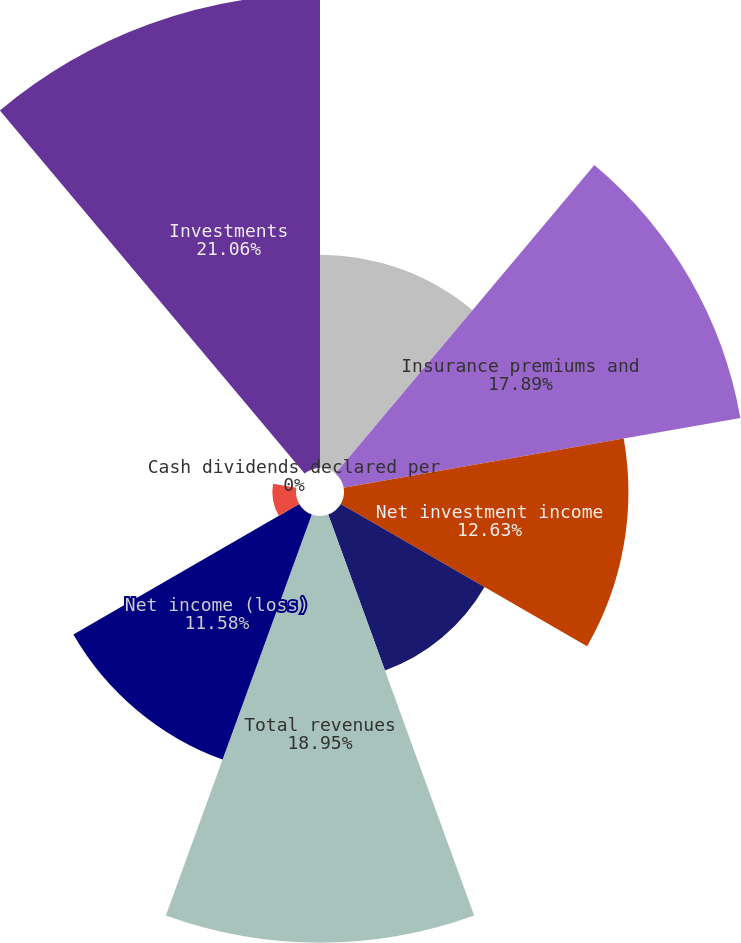<chart> <loc_0><loc_0><loc_500><loc_500><pie_chart><fcel>( in millions except per share<fcel>Insurance premiums and<fcel>Net investment income<fcel>Realized capital gains and<fcel>Total revenues<fcel>Net income (loss)<fcel>Net income (loss) per share -<fcel>Cash dividends declared per<fcel>Investments<nl><fcel>9.47%<fcel>17.89%<fcel>12.63%<fcel>7.37%<fcel>18.95%<fcel>11.58%<fcel>1.05%<fcel>0.0%<fcel>21.05%<nl></chart> 